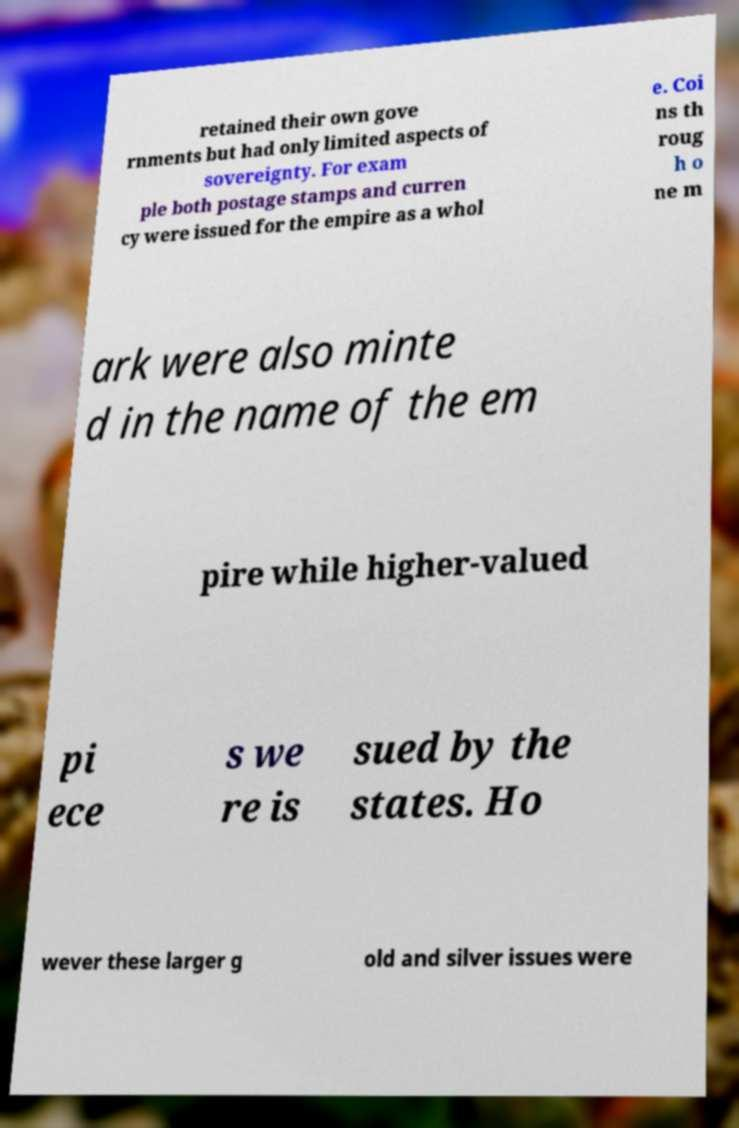There's text embedded in this image that I need extracted. Can you transcribe it verbatim? retained their own gove rnments but had only limited aspects of sovereignty. For exam ple both postage stamps and curren cy were issued for the empire as a whol e. Coi ns th roug h o ne m ark were also minte d in the name of the em pire while higher-valued pi ece s we re is sued by the states. Ho wever these larger g old and silver issues were 